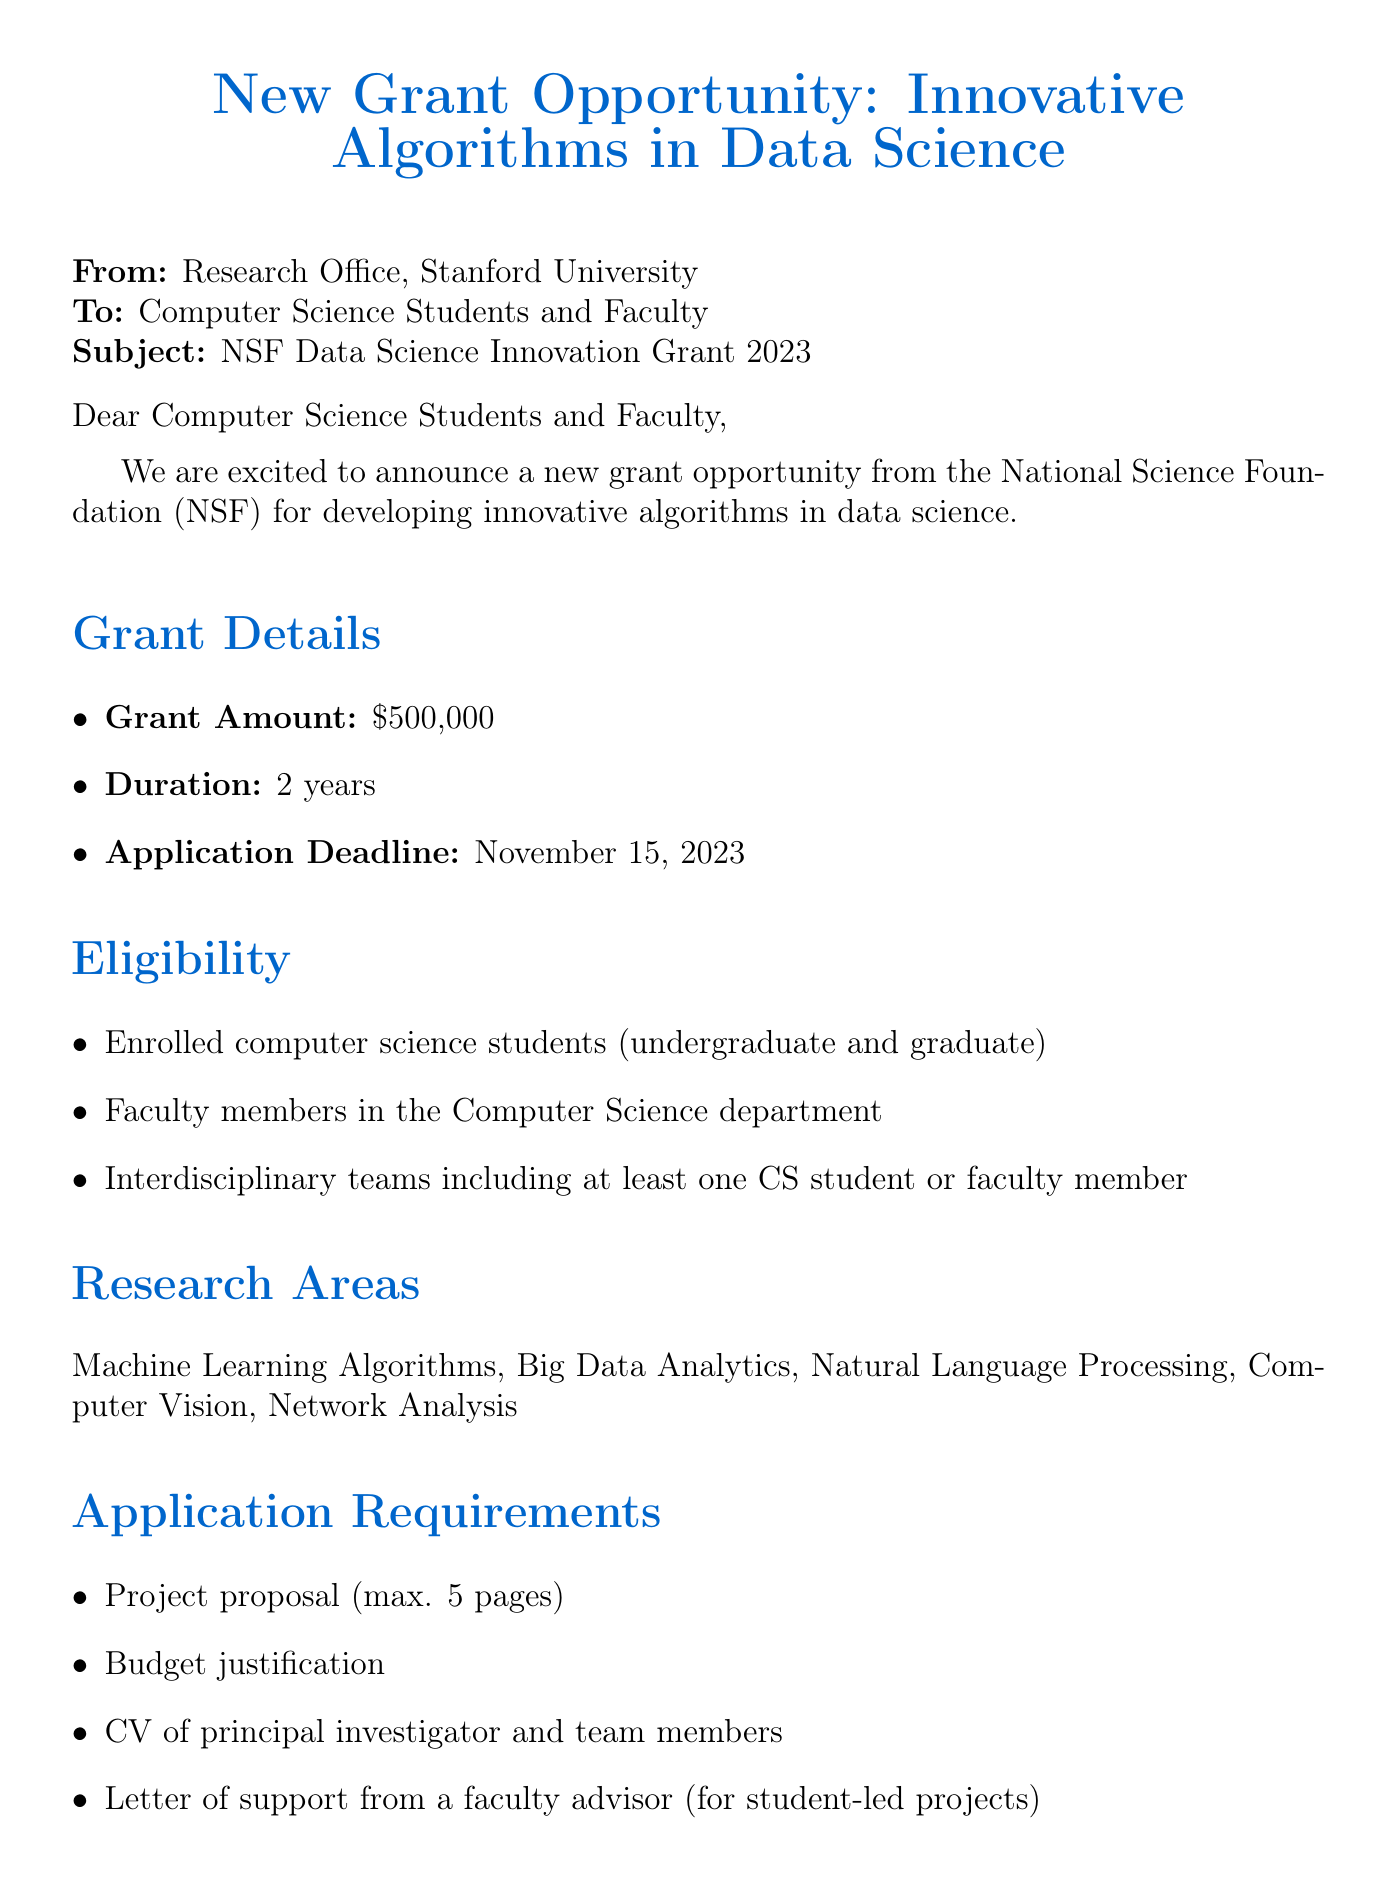what is the grant name? The grant name is provided in the document, which is NSF Data Science Innovation Grant 2023.
Answer: NSF Data Science Innovation Grant 2023 who is the funding body? The funding body is mentioned in the document, which is the National Science Foundation.
Answer: National Science Foundation what is the application deadline? The application deadline is specified in the document, which is November 15, 2023.
Answer: November 15, 2023 how long is the project duration? The project duration is stated in the document, which is 2 years.
Answer: 2 years who is the contact person for more information? The document provides the contact person's name, which is Dr. Sarah Chen.
Answer: Dr. Sarah Chen what types of teams are eligible to apply? The eligibility section specifies that interdisciplinary teams including at least one CS student or faculty member can apply.
Answer: Interdisciplinary teams including at least one CS student or faculty member what is one evaluation criterion? The evaluation criteria include several aspects; one of them is the innovation and originality of the proposed algorithm.
Answer: Innovation and originality of the proposed algorithm when is the information session scheduled? The information session date is stated in the document as October 1, 2023.
Answer: October 1, 2023 what is the registration link for the information session? The document provides a registration link for the information session, which is https://stanford.edu/cs/grants/nsf-info-session.
Answer: https://stanford.edu/cs/grants/nsf-info-session 